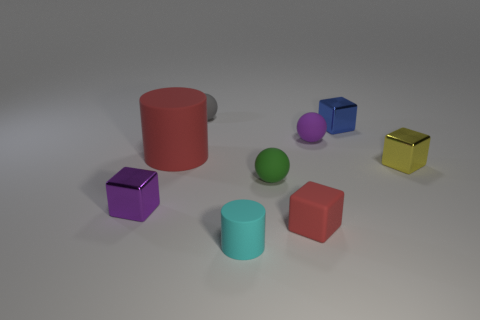Subtract 2 blocks. How many blocks are left? 2 Add 1 small metal balls. How many objects exist? 10 Subtract all brown cubes. Subtract all gray balls. How many cubes are left? 4 Subtract all balls. How many objects are left? 6 Add 1 tiny blue metallic blocks. How many tiny blue metallic blocks exist? 2 Subtract 0 brown cubes. How many objects are left? 9 Subtract all large gray rubber things. Subtract all tiny cyan objects. How many objects are left? 8 Add 5 cyan cylinders. How many cyan cylinders are left? 6 